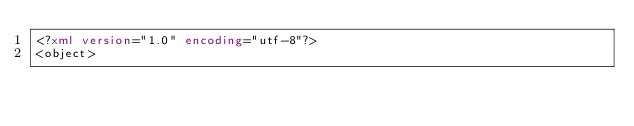<code> <loc_0><loc_0><loc_500><loc_500><_XML_><?xml version="1.0" encoding="utf-8"?>
<object></code> 